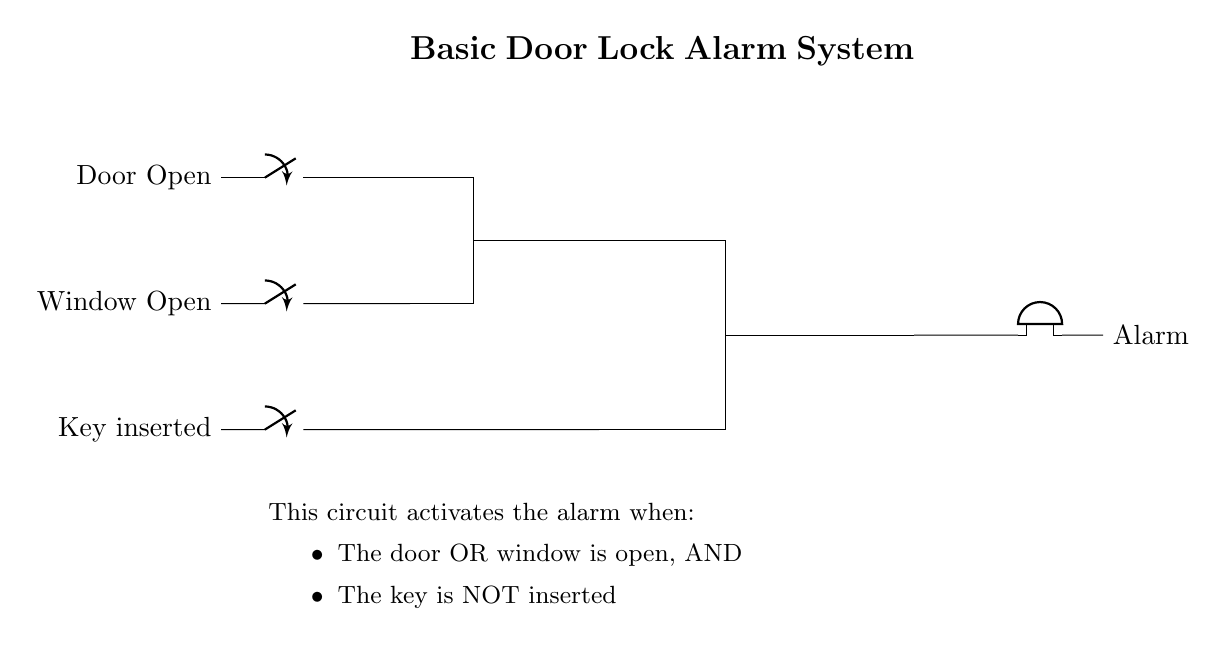What is the main function of this circuit? The circuit activates an alarm when the door or window is open, and the key is not inserted. This is indicated by the connections and logic gates used in the diagram.
Answer: activates alarm How many switches are present in the circuit? The diagram includes two switches: one for the door and one for the window. This is identified by the symbols labeled "Door Open" and "Window Open."
Answer: two switches What type of logic gate is used after the door and window inputs? An OR gate is used, which combines the signals from both the door and window switches to determine if either is open. This is evident from the gate symbol and its connection to the switches.
Answer: OR gate What happens when the key is inserted? When the key is inserted, the NOT gate output will be low (false), allowing the AND gate to process its inputs from the OR gate without activating the alarm. This shows how the key's state impacts the alarm condition.
Answer: alarm may not activate What are the conditions for the alarm to sound? The alarm sounds if either the door or window is open and the key is not inserted. This is derived from the combination of the OR gate for the door and window and the NOT gate for the key.
Answer: door or window open, key not inserted What does the buzzer represent in this circuit? The buzzer represents the alarm that sounds when the circuit conditions are met (door/window open and no key). This is the final output of the circuit, illustrated at the end of the circuit diagram.
Answer: alarm 